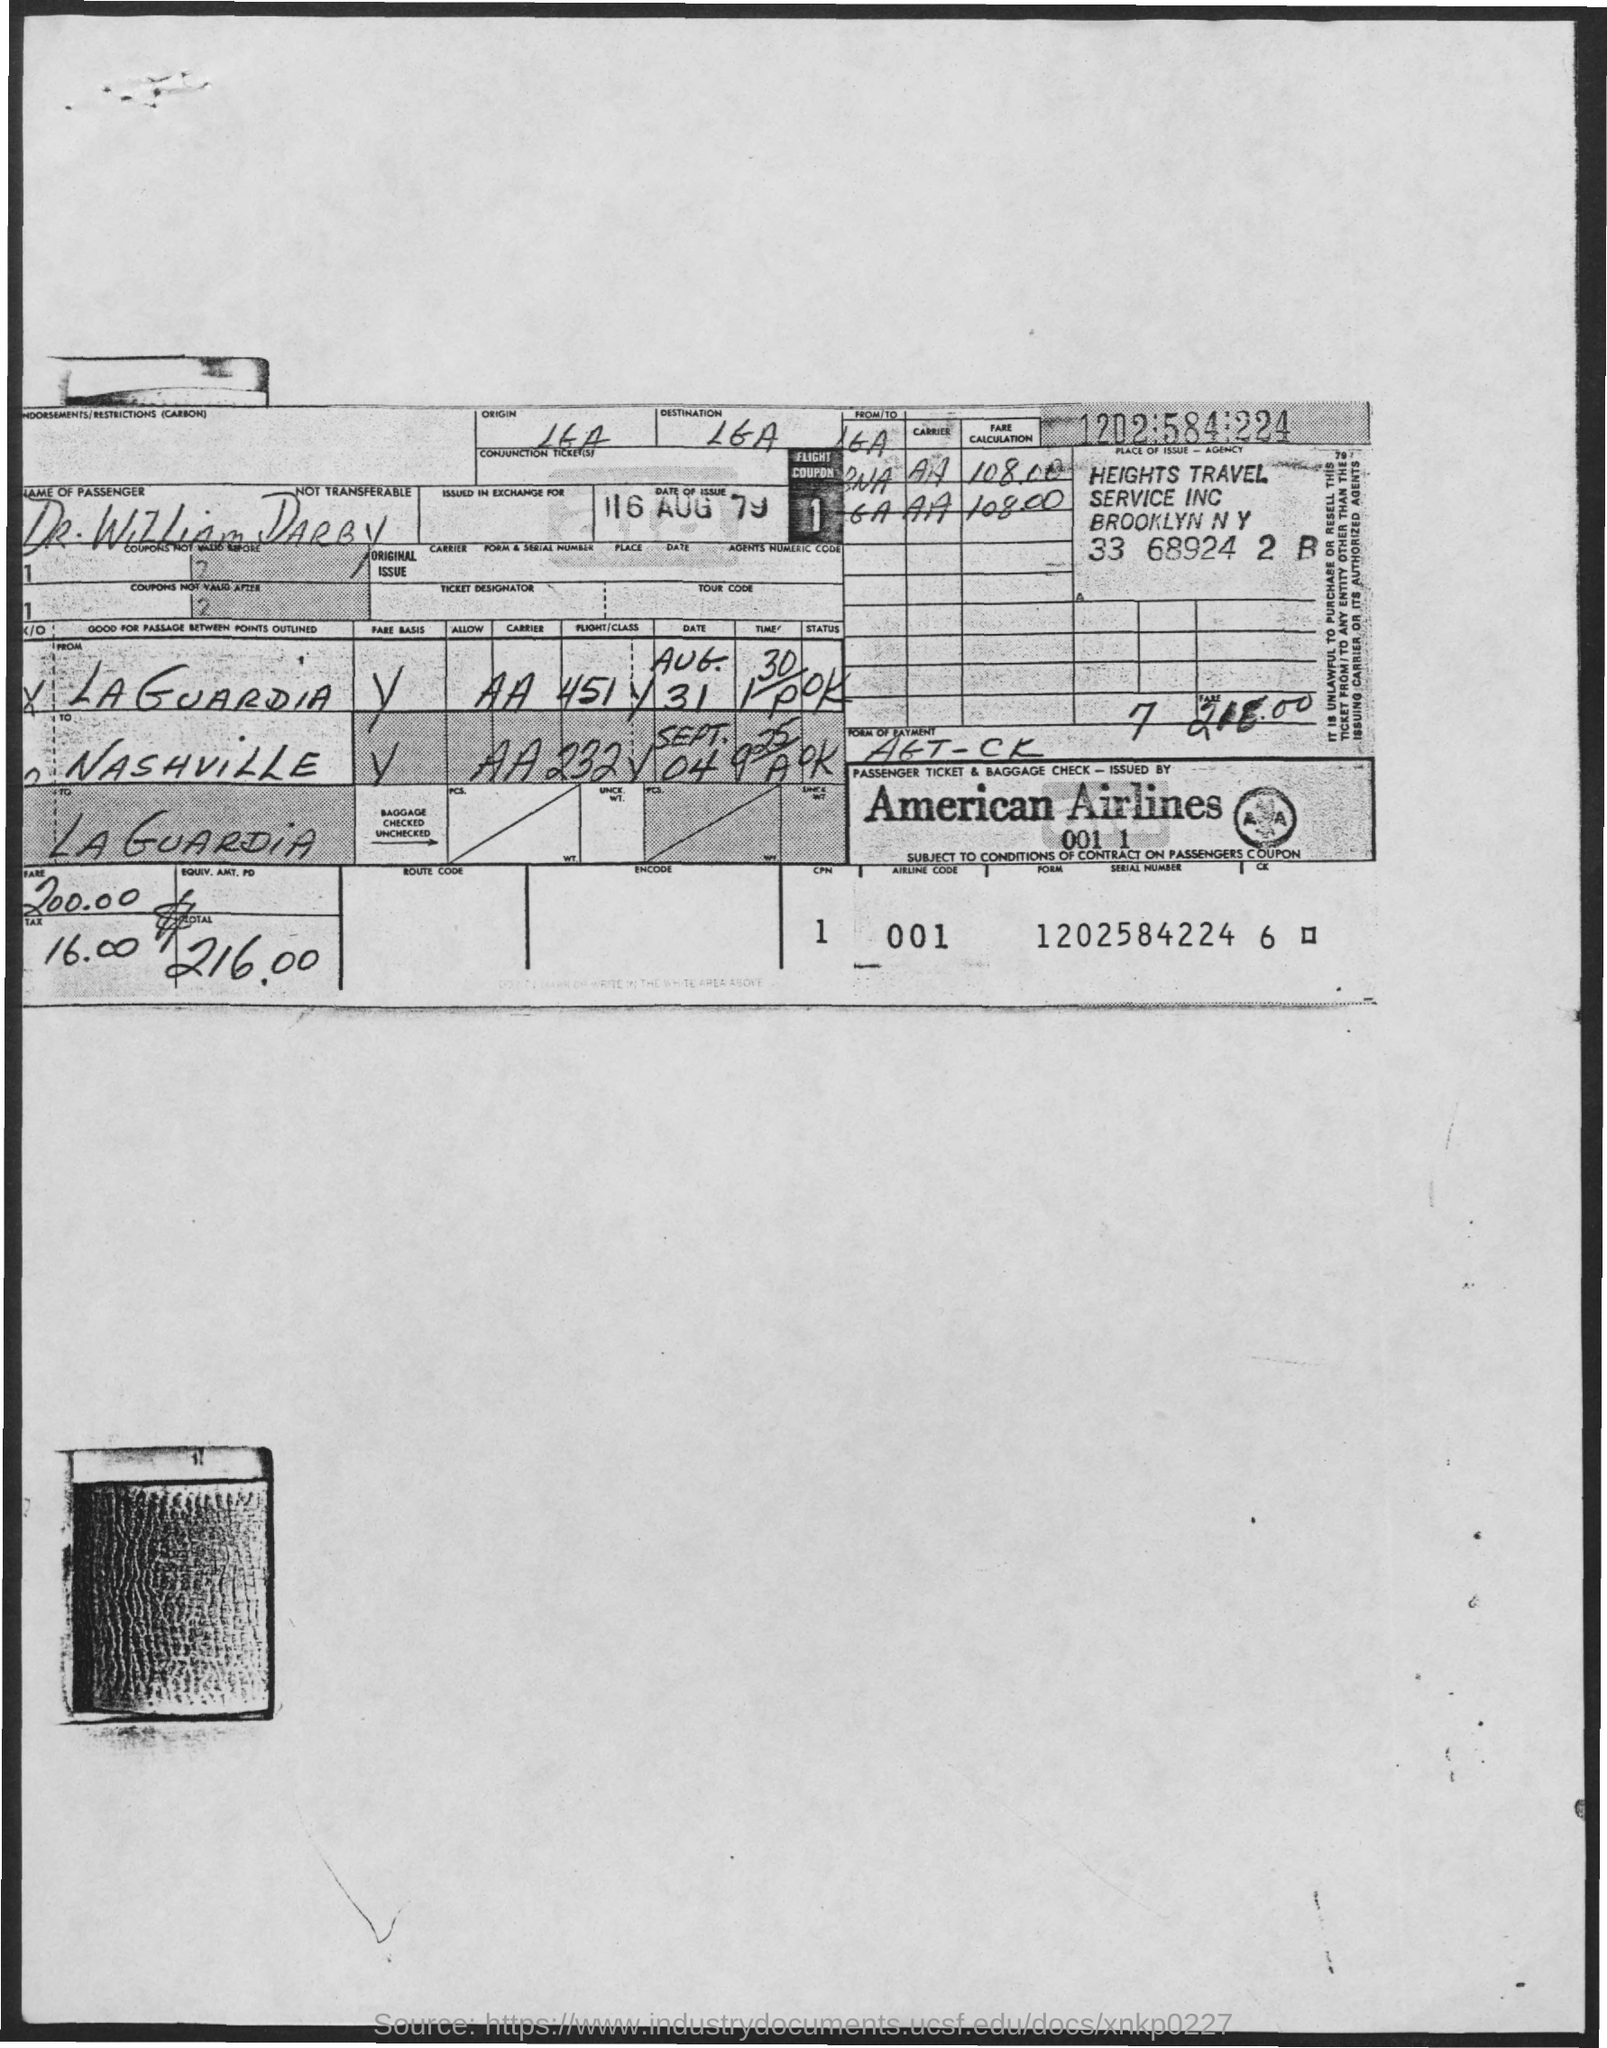Outline some significant characteristics in this image. The passenger's name is Dr. William Darby. The date of issue is August 16th, 1979. 